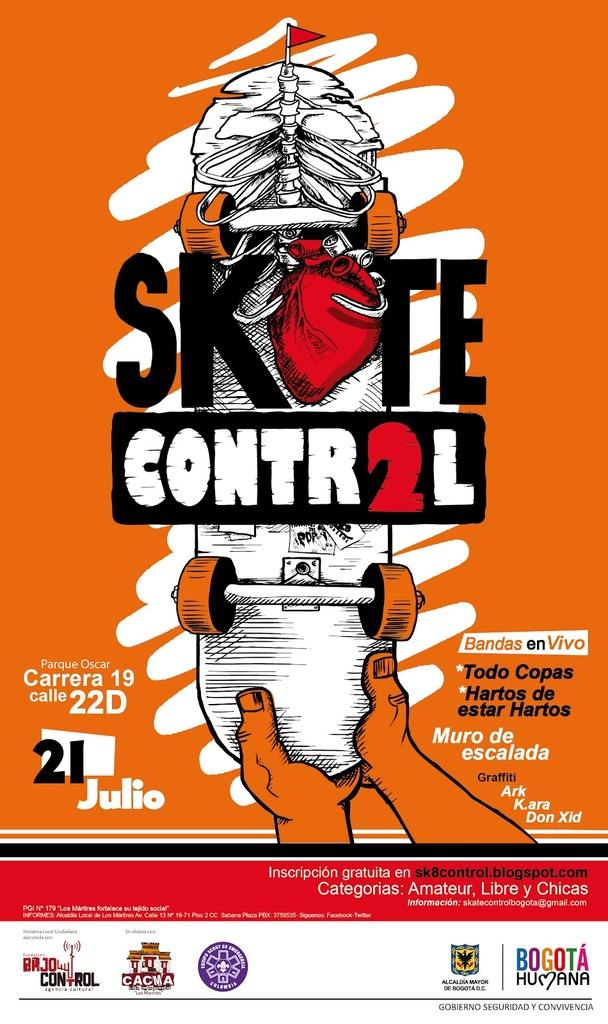<image>
Give a short and clear explanation of the subsequent image. A poster for an event called Skate Contro2l. 